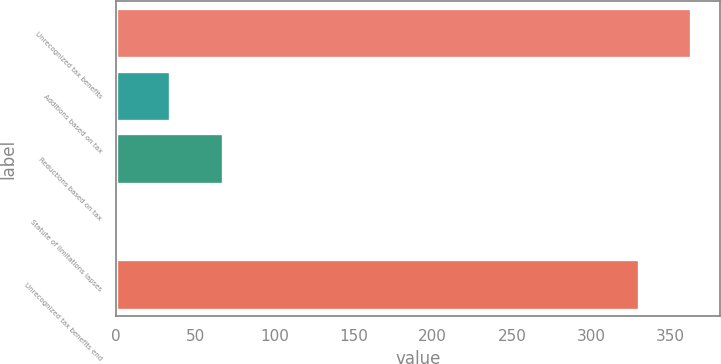<chart> <loc_0><loc_0><loc_500><loc_500><bar_chart><fcel>Unrecognized tax benefits<fcel>Additions based on tax<fcel>Reductions based on tax<fcel>Statute of limitations lapses<fcel>Unrecognized tax benefits end<nl><fcel>363.2<fcel>34.2<fcel>67.4<fcel>1<fcel>330<nl></chart> 